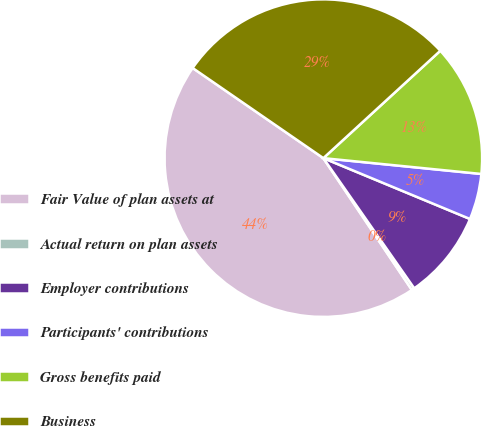<chart> <loc_0><loc_0><loc_500><loc_500><pie_chart><fcel>Fair Value of plan assets at<fcel>Actual return on plan assets<fcel>Employer contributions<fcel>Participants' contributions<fcel>Gross benefits paid<fcel>Business<nl><fcel>44.02%<fcel>0.29%<fcel>9.04%<fcel>4.67%<fcel>13.41%<fcel>28.57%<nl></chart> 